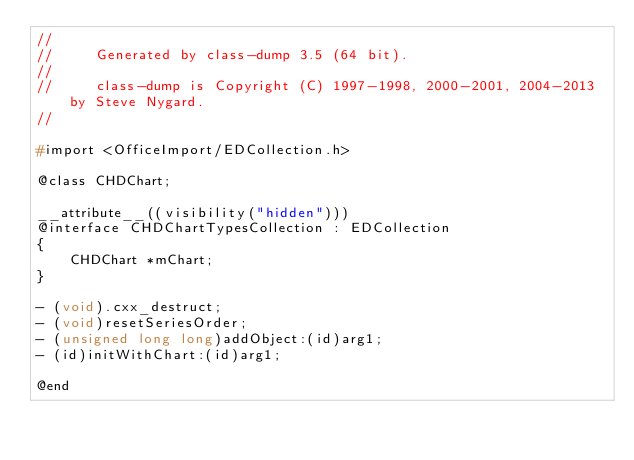<code> <loc_0><loc_0><loc_500><loc_500><_C_>//
//     Generated by class-dump 3.5 (64 bit).
//
//     class-dump is Copyright (C) 1997-1998, 2000-2001, 2004-2013 by Steve Nygard.
//

#import <OfficeImport/EDCollection.h>

@class CHDChart;

__attribute__((visibility("hidden")))
@interface CHDChartTypesCollection : EDCollection
{
    CHDChart *mChart;
}

- (void).cxx_destruct;
- (void)resetSeriesOrder;
- (unsigned long long)addObject:(id)arg1;
- (id)initWithChart:(id)arg1;

@end

</code> 